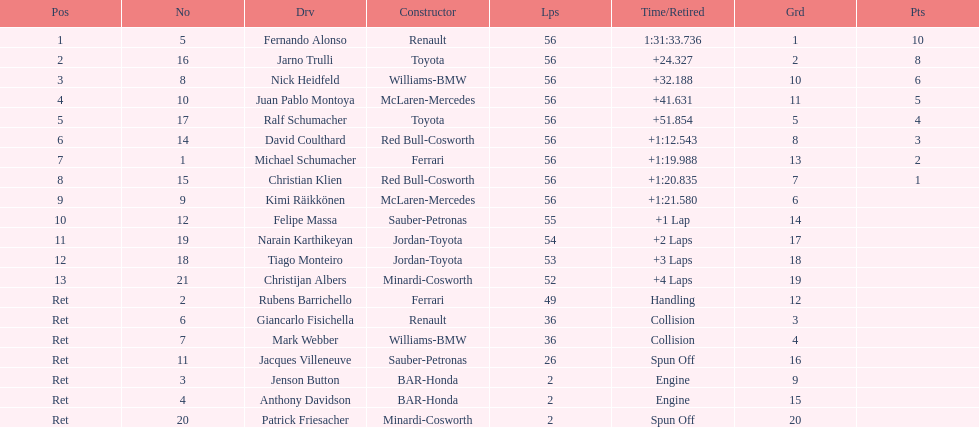How many bmws finished before webber? 1. 